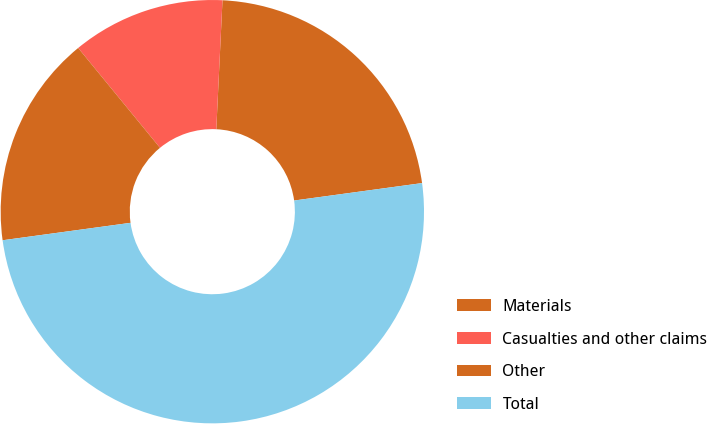Convert chart. <chart><loc_0><loc_0><loc_500><loc_500><pie_chart><fcel>Materials<fcel>Casualties and other claims<fcel>Other<fcel>Total<nl><fcel>22.08%<fcel>11.69%<fcel>16.23%<fcel>50.0%<nl></chart> 